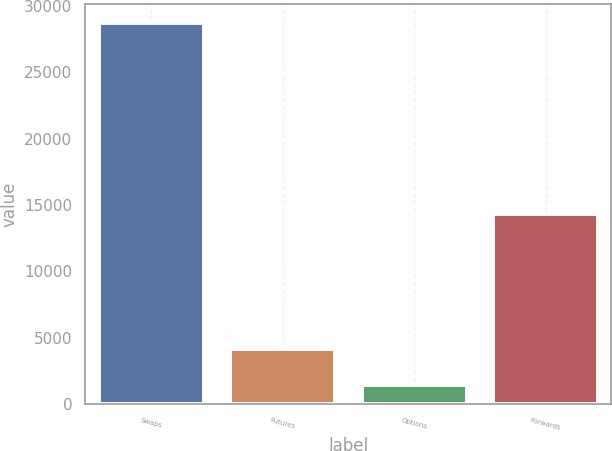<chart> <loc_0><loc_0><loc_500><loc_500><bar_chart><fcel>Swaps<fcel>Futures<fcel>Options<fcel>Forwards<nl><fcel>28730<fcel>4184.3<fcel>1457<fcel>14303<nl></chart> 